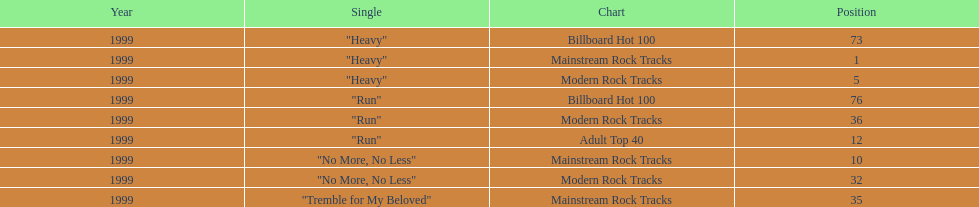How many songs from the album "dosage" were featured on the modern rock tracks charts? 3. 